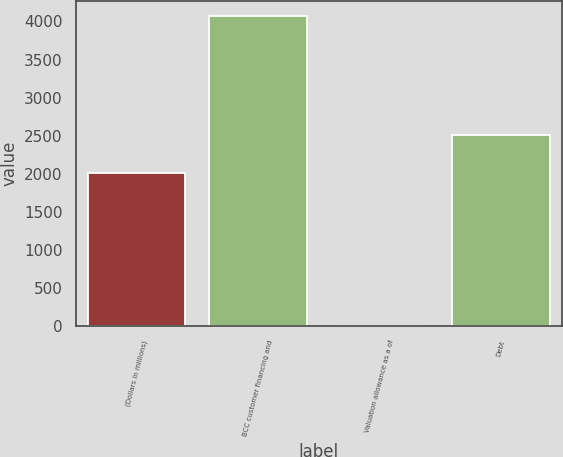<chart> <loc_0><loc_0><loc_500><loc_500><bar_chart><fcel>(Dollars in millions)<fcel>BCC customer financing and<fcel>Valuation allowance as a of<fcel>Debt<nl><fcel>2012<fcel>4066<fcel>2<fcel>2511<nl></chart> 